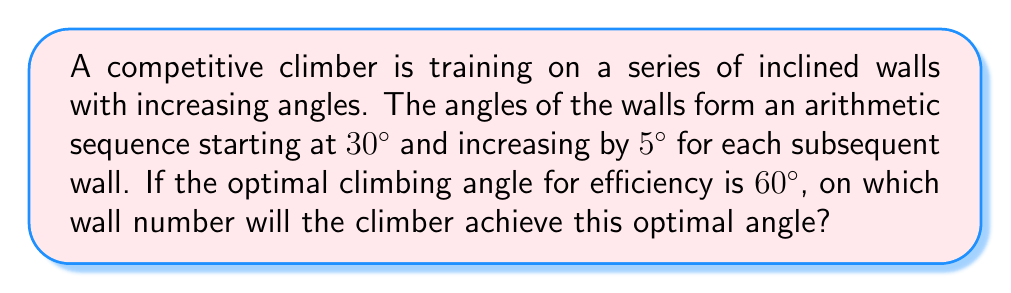Show me your answer to this math problem. Let's approach this step-by-step:

1) We're dealing with an arithmetic sequence where:
   - First term, $a_1 = 30°$
   - Common difference, $d = 5°$
   - We need to find the term number $n$ where $a_n = 60°$

2) The general formula for the nth term of an arithmetic sequence is:
   $a_n = a_1 + (n-1)d$

3) Substituting our values:
   $60 = 30 + (n-1)5$

4) Solving for $n$:
   $60 - 30 = (n-1)5$
   $30 = (n-1)5$
   $6 = n-1$
   $n = 7$

5) Therefore, the 7th wall will have an angle of 60°.

To verify:
$a_7 = 30 + (7-1)5 = 30 + 30 = 60°$
Answer: 7th wall 